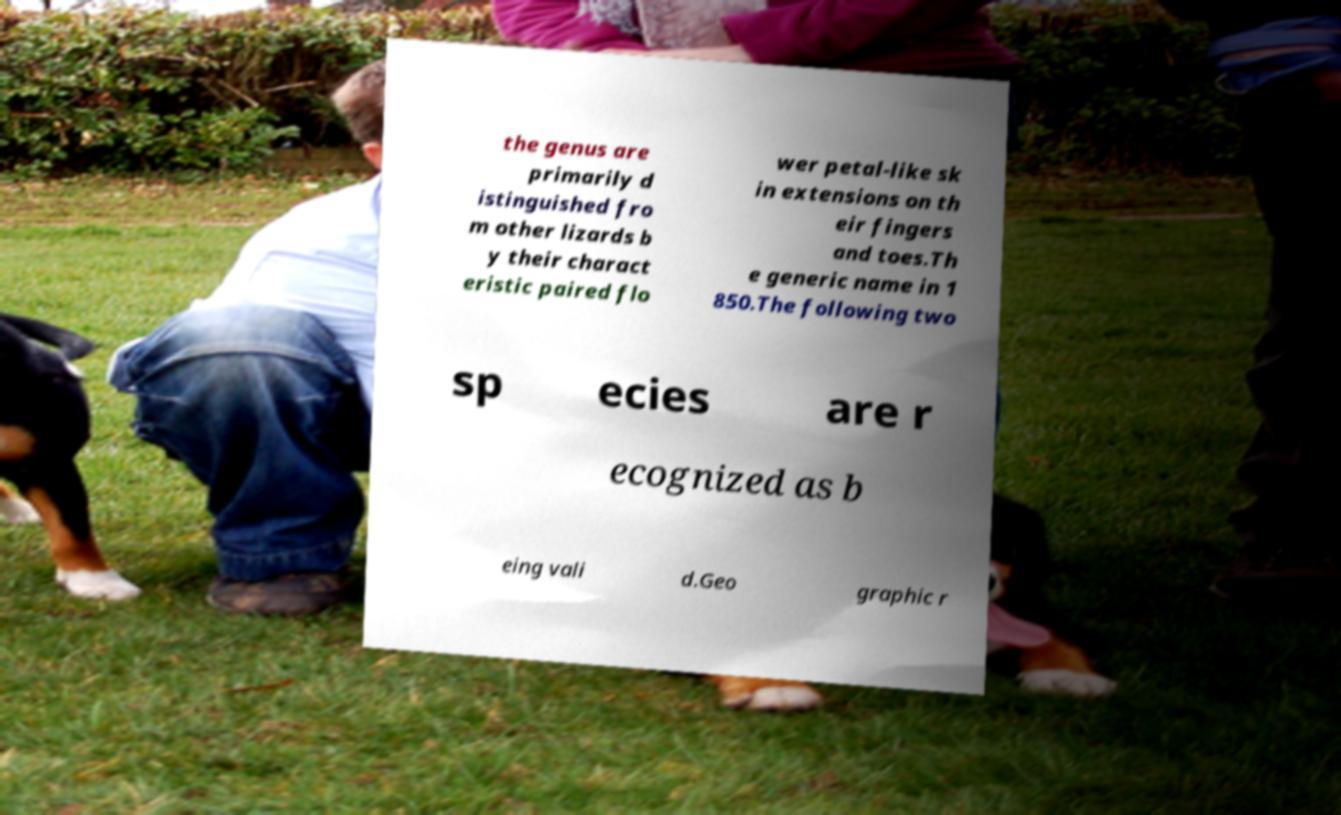There's text embedded in this image that I need extracted. Can you transcribe it verbatim? the genus are primarily d istinguished fro m other lizards b y their charact eristic paired flo wer petal-like sk in extensions on th eir fingers and toes.Th e generic name in 1 850.The following two sp ecies are r ecognized as b eing vali d.Geo graphic r 